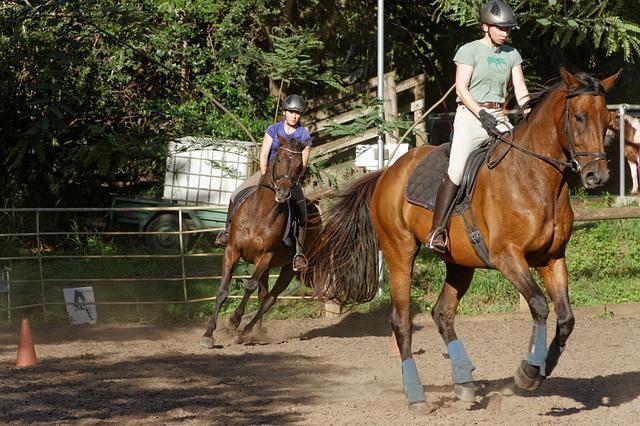Why do the people wear head gear?
Choose the right answer from the provided options to respond to the question.
Options: Fashion, streamlining, protection, to match. Protection. 